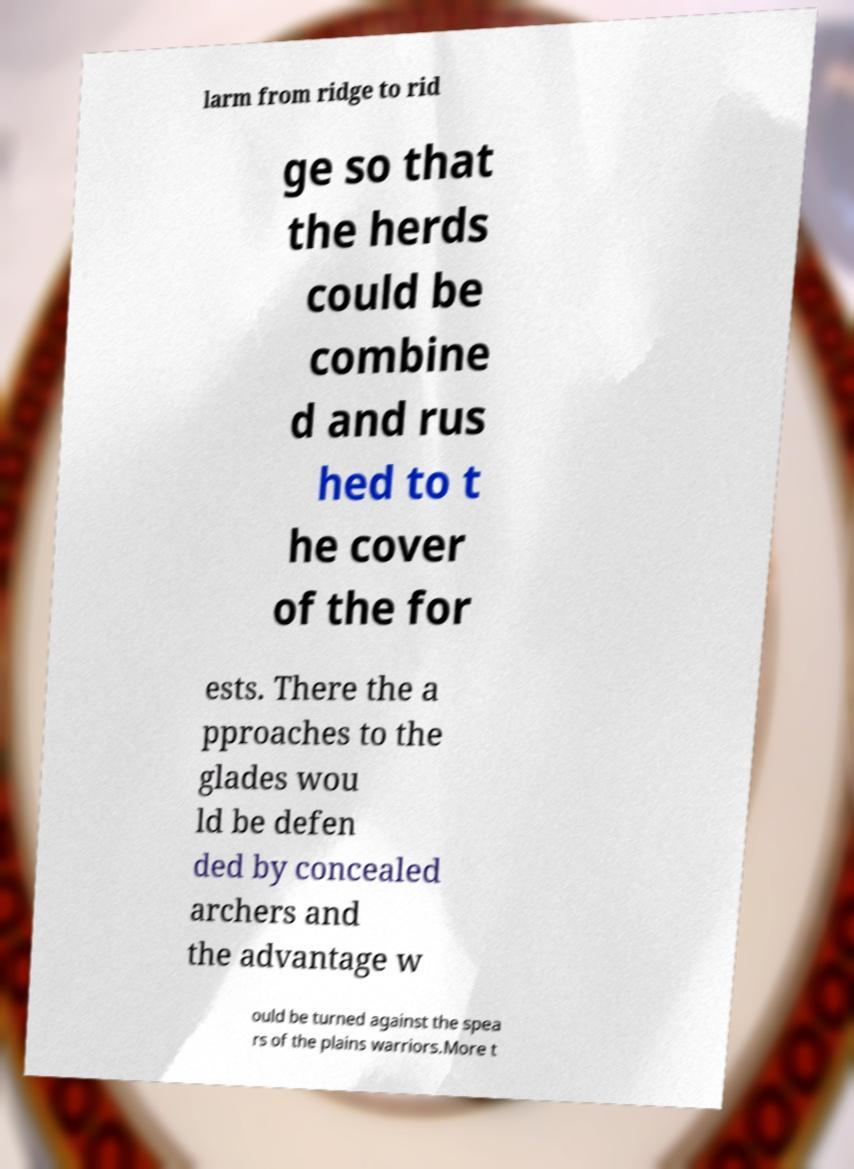For documentation purposes, I need the text within this image transcribed. Could you provide that? larm from ridge to rid ge so that the herds could be combine d and rus hed to t he cover of the for ests. There the a pproaches to the glades wou ld be defen ded by concealed archers and the advantage w ould be turned against the spea rs of the plains warriors.More t 